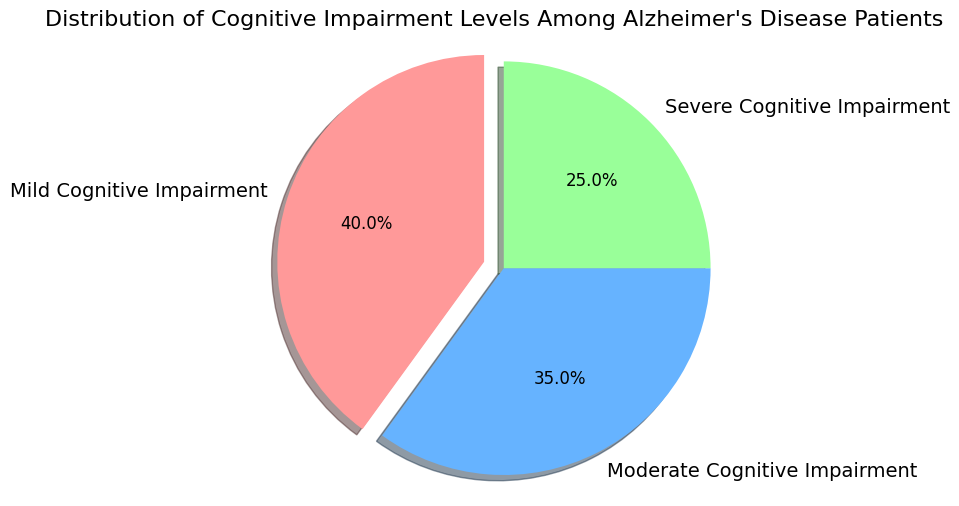What is the largest segment in the pie chart? The largest segment in the pie chart corresponds to the label with the highest percentage. By visual inspection, the "Mild Cognitive Impairment" segment is the largest.
Answer: Mild Cognitive Impairment Which category has a percentage higher than 30% but lower than 40%? To find the category between 30% and 40%, I inspect the labeled percentages. The "Moderate Cognitive Impairment" category has a percentage of 35%, which falls within the specified range.
Answer: Moderate Cognitive Impairment By how much is the "Mild Cognitive Impairment" percentage larger than the "Severe Cognitive Impairment" percentage? Subtract the percentage of "Severe Cognitive Impairment" from "Mild Cognitive Impairment" to find the difference: 40% - 25% = 15%.
Answer: 15% What fraction of the total patient population is represented by the "Severe Cognitive Impairment" category? The fraction is given by the percentage value divided by 100. For "Severe Cognitive Impairment", this is 25%/100, which simplifies to 1/4 or 0.25.
Answer: 1/4 Compare the size of the "Moderate Cognitive Impairment" segment to the "Severe Cognitive Impairment" segment. Which is larger? The "Moderate Cognitive Impairment" segment is 35% while the "Severe Cognitive Impairment" segment is 25%. Comparing these, 35% is larger than 25%.
Answer: Moderate Cognitive Impairment What combined percentage do the "Moderate" and "Severe Cognitive Impairment" categories represent? Add the percentages of the "Moderate Cognitive Impairment" and "Severe Cognitive Impairment" categories together: 35% + 25% = 60%.
Answer: 60% What is the visual attribute that emphasizes the "Mild Cognitive Impairment" category in the pie chart? The "Mild Cognitive Impairment" segment is visually emphasized by being slightly exploded out from the rest of the pie chart.
Answer: Explode Which category’s segment starts from the top center and moves clockwise? By observing the initial positioning in a pie chart which generally starts at the top center, the first category arranged clockwise is "Mild Cognitive Impairment".
Answer: Mild Cognitive Impairment If one were to combine "Moderate" and "Severe Cognitive Impairment" into one category, how would the visual representation change? Combining both would result in a single segment that represents the sum of their percentages: 35% + 25% = 60%. This new segment would visually be larger than any existing single segment.
Answer: New combined segment of 60% 